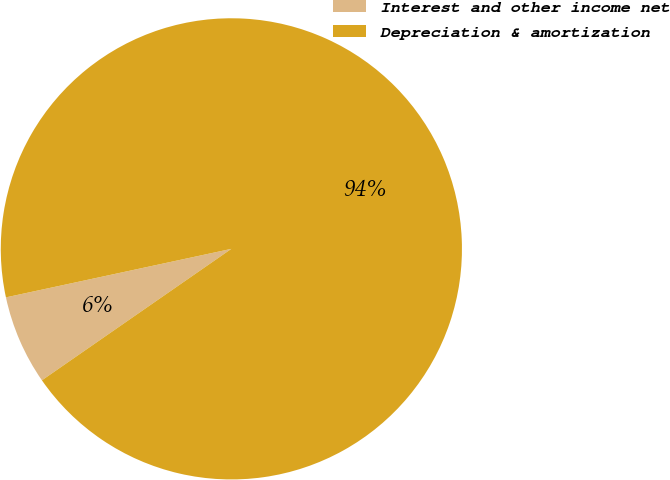Convert chart. <chart><loc_0><loc_0><loc_500><loc_500><pie_chart><fcel>Interest and other income net<fcel>Depreciation & amortization<nl><fcel>6.28%<fcel>93.72%<nl></chart> 